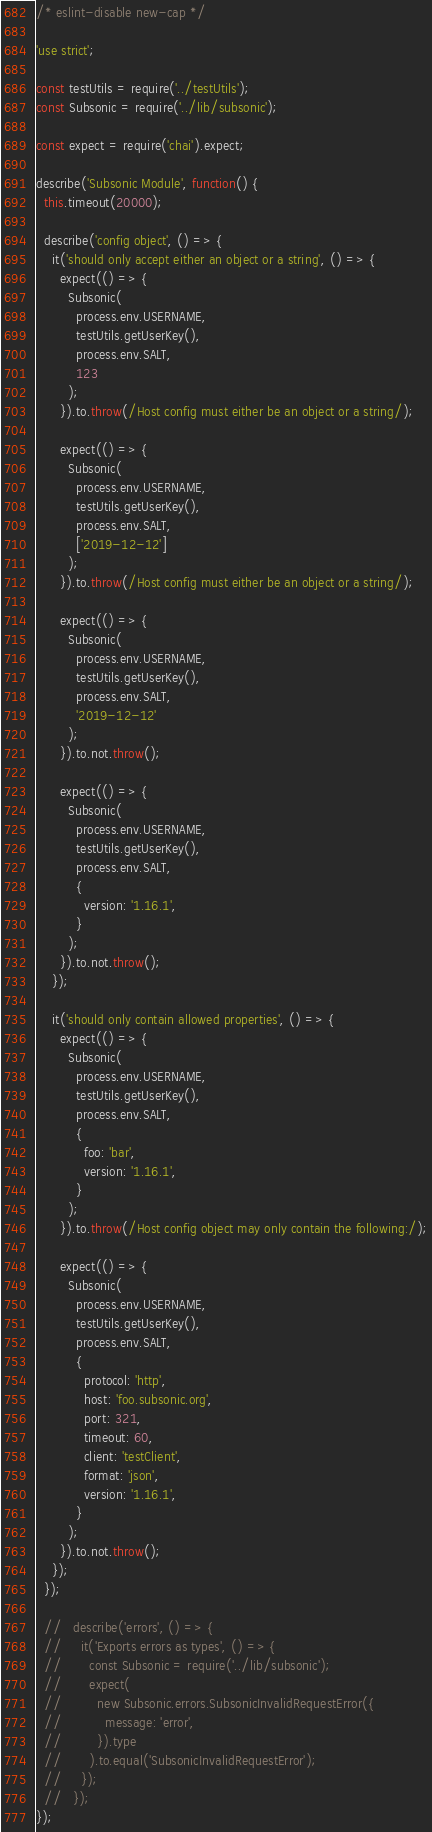<code> <loc_0><loc_0><loc_500><loc_500><_JavaScript_>/* eslint-disable new-cap */

'use strict';

const testUtils = require('../testUtils');
const Subsonic = require('../lib/subsonic');

const expect = require('chai').expect;

describe('Subsonic Module', function() {
  this.timeout(20000);

  describe('config object', () => {
    it('should only accept either an object or a string', () => {
      expect(() => {
        Subsonic(
          process.env.USERNAME,
          testUtils.getUserKey(),
          process.env.SALT,
          123
        );
      }).to.throw(/Host config must either be an object or a string/);

      expect(() => {
        Subsonic(
          process.env.USERNAME,
          testUtils.getUserKey(),
          process.env.SALT,
          ['2019-12-12']
        );
      }).to.throw(/Host config must either be an object or a string/);

      expect(() => {
        Subsonic(
          process.env.USERNAME,
          testUtils.getUserKey(),
          process.env.SALT,
          '2019-12-12'
        );
      }).to.not.throw();

      expect(() => {
        Subsonic(
          process.env.USERNAME,
          testUtils.getUserKey(),
          process.env.SALT,
          {
            version: '1.16.1',
          }
        );
      }).to.not.throw();
    });

    it('should only contain allowed properties', () => {
      expect(() => {
        Subsonic(
          process.env.USERNAME,
          testUtils.getUserKey(),
          process.env.SALT,
          {
            foo: 'bar',
            version: '1.16.1',
          }
        );
      }).to.throw(/Host config object may only contain the following:/);

      expect(() => {
        Subsonic(
          process.env.USERNAME,
          testUtils.getUserKey(),
          process.env.SALT,
          {
            protocol: 'http',
            host: 'foo.subsonic.org',
            port: 321,
            timeout: 60,
            client: 'testClient',
            format: 'json',
            version: '1.16.1',
          }
        );
      }).to.not.throw();
    });
  });

  //   describe('errors', () => {
  //     it('Exports errors as types', () => {
  //       const Subsonic = require('../lib/subsonic');
  //       expect(
  //         new Subsonic.errors.SubsonicInvalidRequestError({
  //           message: 'error',
  //         }).type
  //       ).to.equal('SubsonicInvalidRequestError');
  //     });
  //   });
});
</code> 